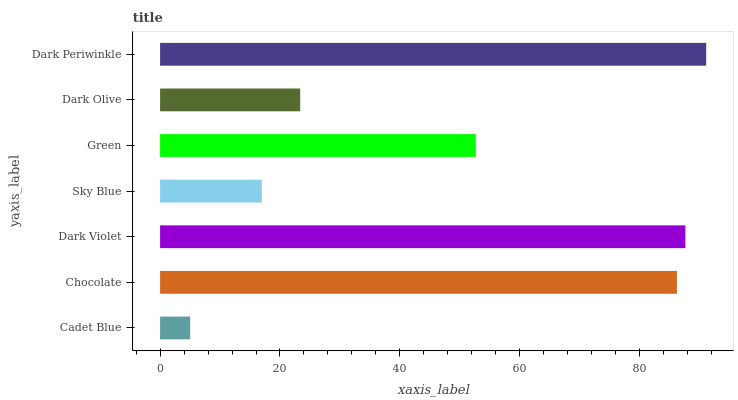Is Cadet Blue the minimum?
Answer yes or no. Yes. Is Dark Periwinkle the maximum?
Answer yes or no. Yes. Is Chocolate the minimum?
Answer yes or no. No. Is Chocolate the maximum?
Answer yes or no. No. Is Chocolate greater than Cadet Blue?
Answer yes or no. Yes. Is Cadet Blue less than Chocolate?
Answer yes or no. Yes. Is Cadet Blue greater than Chocolate?
Answer yes or no. No. Is Chocolate less than Cadet Blue?
Answer yes or no. No. Is Green the high median?
Answer yes or no. Yes. Is Green the low median?
Answer yes or no. Yes. Is Cadet Blue the high median?
Answer yes or no. No. Is Sky Blue the low median?
Answer yes or no. No. 